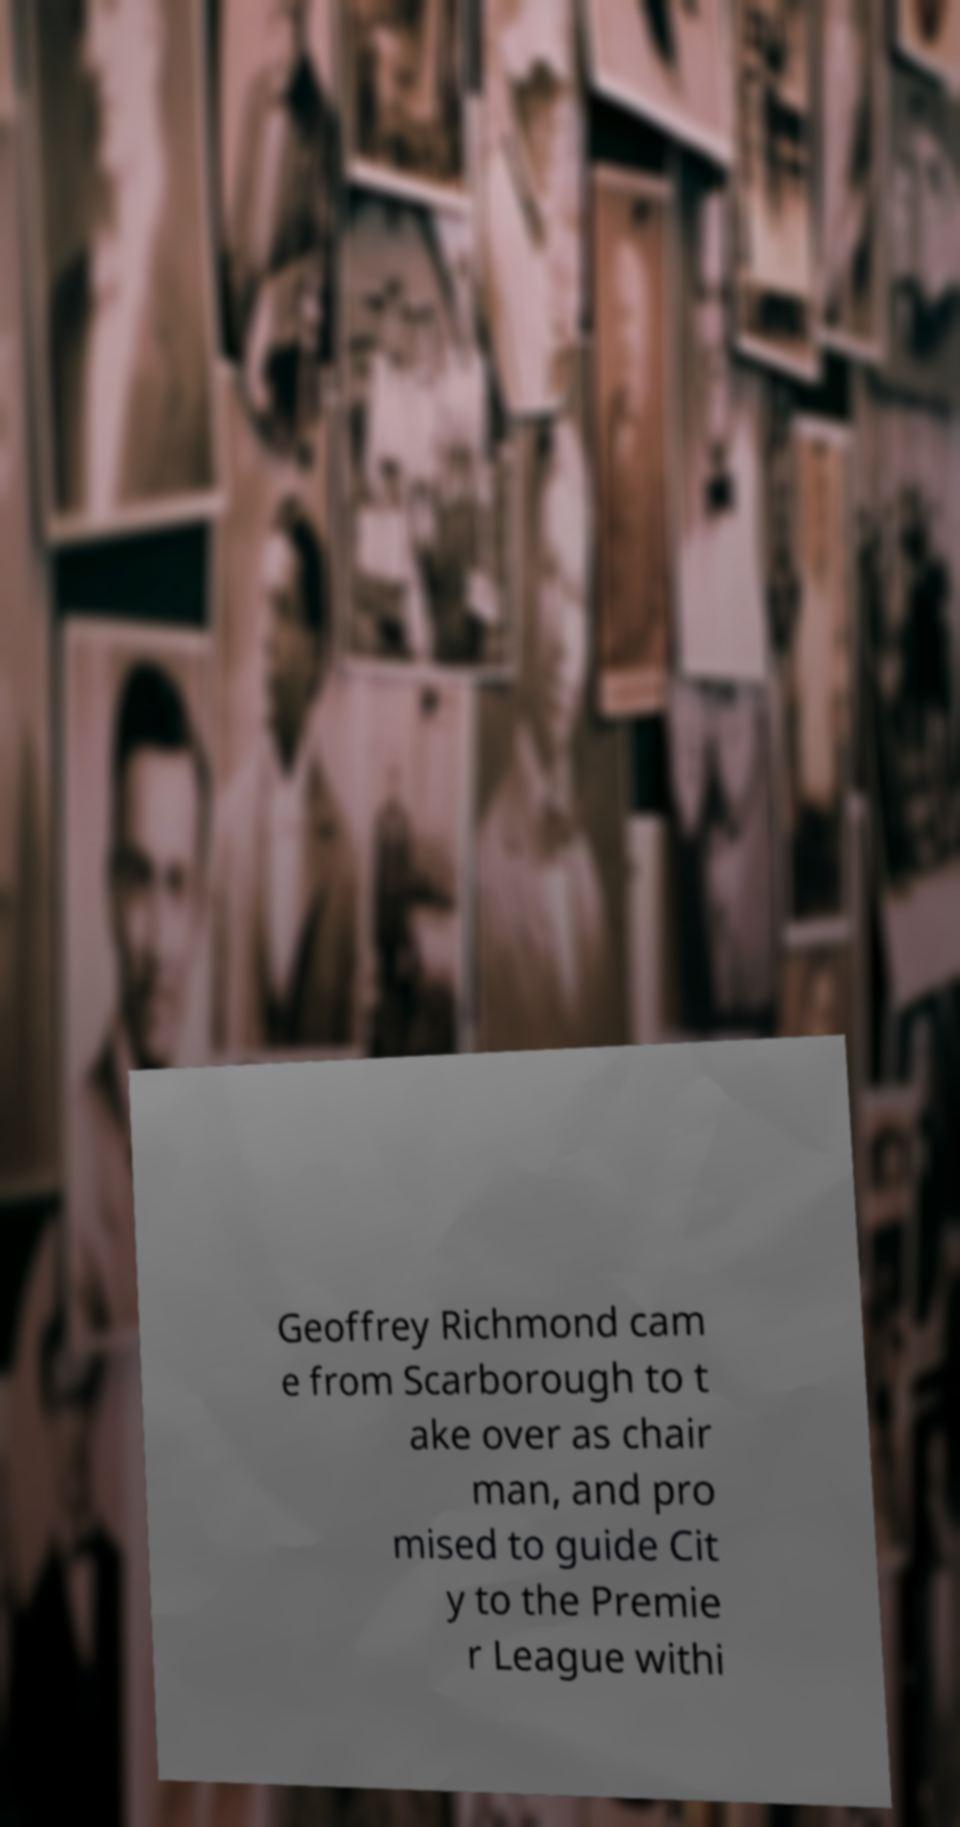Please read and relay the text visible in this image. What does it say? Geoffrey Richmond cam e from Scarborough to t ake over as chair man, and pro mised to guide Cit y to the Premie r League withi 